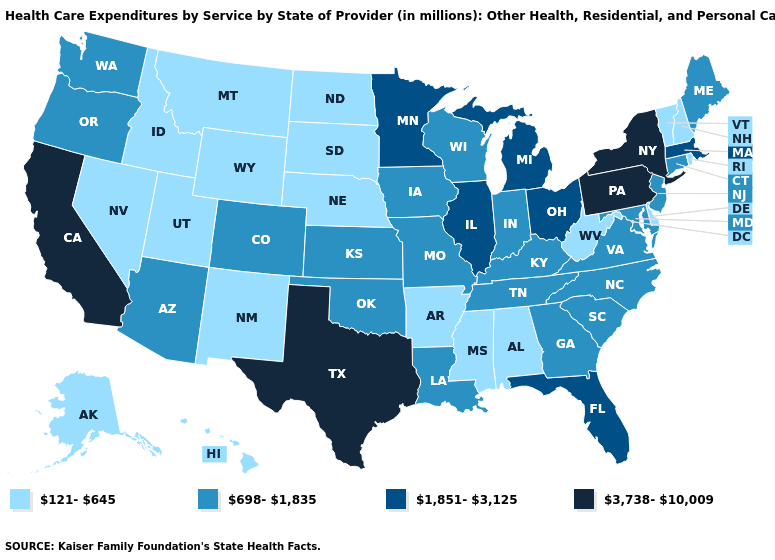What is the lowest value in the USA?
Concise answer only. 121-645. Among the states that border Mississippi , does Tennessee have the highest value?
Be succinct. Yes. What is the highest value in the USA?
Answer briefly. 3,738-10,009. Name the states that have a value in the range 698-1,835?
Keep it brief. Arizona, Colorado, Connecticut, Georgia, Indiana, Iowa, Kansas, Kentucky, Louisiana, Maine, Maryland, Missouri, New Jersey, North Carolina, Oklahoma, Oregon, South Carolina, Tennessee, Virginia, Washington, Wisconsin. Among the states that border Vermont , which have the highest value?
Short answer required. New York. Does California have the highest value in the USA?
Write a very short answer. Yes. Which states hav the highest value in the Northeast?
Write a very short answer. New York, Pennsylvania. Name the states that have a value in the range 3,738-10,009?
Concise answer only. California, New York, Pennsylvania, Texas. What is the lowest value in states that border Montana?
Answer briefly. 121-645. Name the states that have a value in the range 121-645?
Write a very short answer. Alabama, Alaska, Arkansas, Delaware, Hawaii, Idaho, Mississippi, Montana, Nebraska, Nevada, New Hampshire, New Mexico, North Dakota, Rhode Island, South Dakota, Utah, Vermont, West Virginia, Wyoming. What is the highest value in states that border Rhode Island?
Short answer required. 1,851-3,125. What is the value of Wisconsin?
Answer briefly. 698-1,835. Does Idaho have a higher value than New Mexico?
Answer briefly. No. What is the value of Alaska?
Write a very short answer. 121-645. What is the highest value in the USA?
Write a very short answer. 3,738-10,009. 